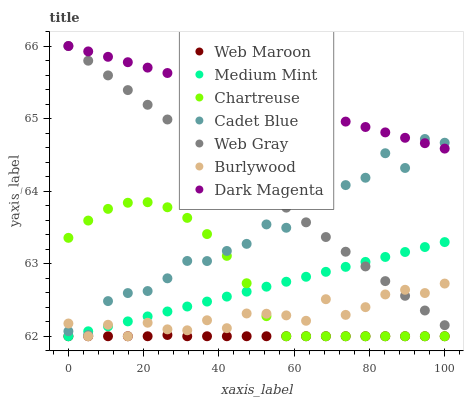Does Web Maroon have the minimum area under the curve?
Answer yes or no. Yes. Does Dark Magenta have the maximum area under the curve?
Answer yes or no. Yes. Does Cadet Blue have the minimum area under the curve?
Answer yes or no. No. Does Cadet Blue have the maximum area under the curve?
Answer yes or no. No. Is Medium Mint the smoothest?
Answer yes or no. Yes. Is Cadet Blue the roughest?
Answer yes or no. Yes. Is Dark Magenta the smoothest?
Answer yes or no. No. Is Dark Magenta the roughest?
Answer yes or no. No. Does Medium Mint have the lowest value?
Answer yes or no. Yes. Does Cadet Blue have the lowest value?
Answer yes or no. No. Does Web Gray have the highest value?
Answer yes or no. Yes. Does Cadet Blue have the highest value?
Answer yes or no. No. Is Chartreuse less than Web Gray?
Answer yes or no. Yes. Is Dark Magenta greater than Web Maroon?
Answer yes or no. Yes. Does Web Maroon intersect Medium Mint?
Answer yes or no. Yes. Is Web Maroon less than Medium Mint?
Answer yes or no. No. Is Web Maroon greater than Medium Mint?
Answer yes or no. No. Does Chartreuse intersect Web Gray?
Answer yes or no. No. 